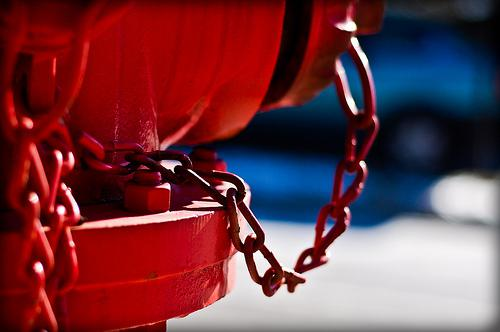Question: what is red?
Choices:
A. The grass.
B. Fire hydrant.
C. The sky.
D. The pavement.
Answer with the letter. Answer: B Question: what is hooked up to hydrant?
Choices:
A. Wires.
B. Rope.
C. Hose.
D. A balloon.
Answer with the letter. Answer: C Question: what comes out of hydrant?
Choices:
A. Spray.
B. Water.
C. Foam.
D. Air.
Answer with the letter. Answer: B Question: who use this hydrant?
Choices:
A. Firefighters.
B. Neighbor kids.
C. City workers.
D. Dogs.
Answer with the letter. Answer: A 